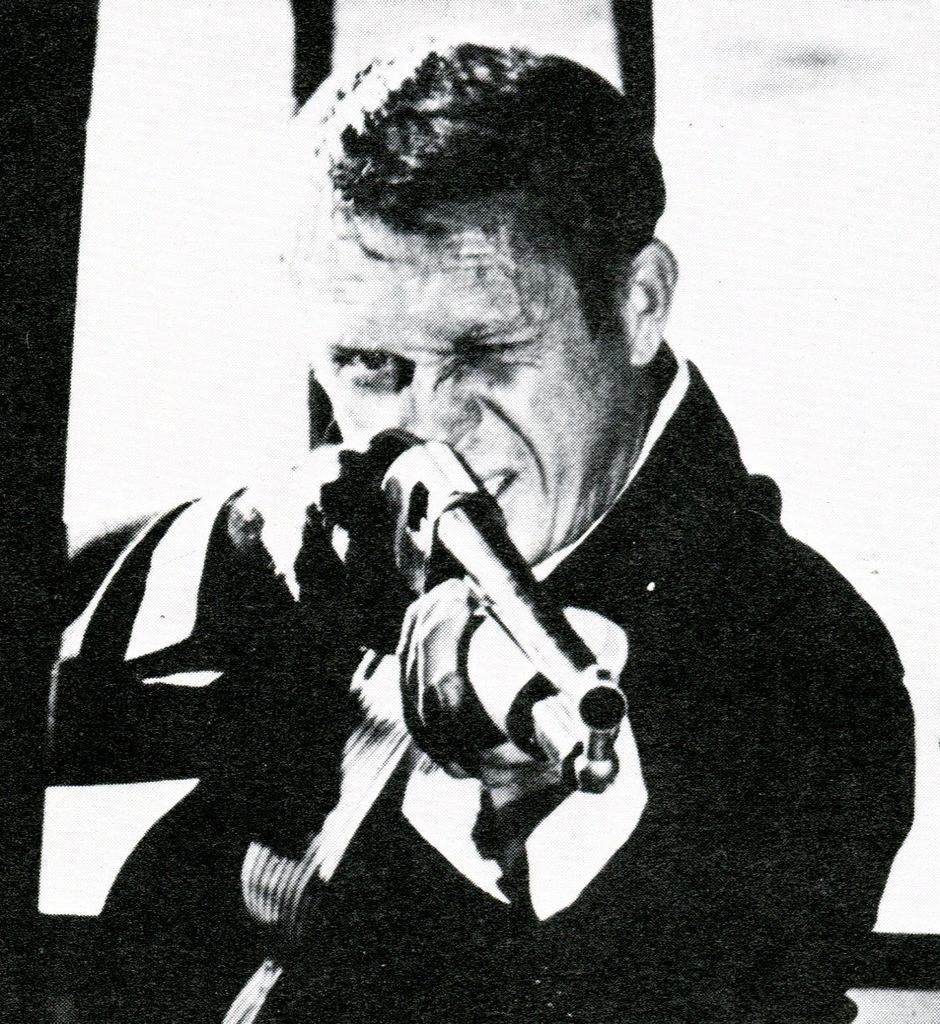Who is the main subject in the foreground of the image? There is a man in the foreground of the image. What is the man holding in the image? The man is holding a gun in the image. What is the color scheme of the image? The image is black and white. What grade does the man receive for his performance in the image? There is no indication of a performance or grading system in the image, as it simply shows a man holding a gun. 